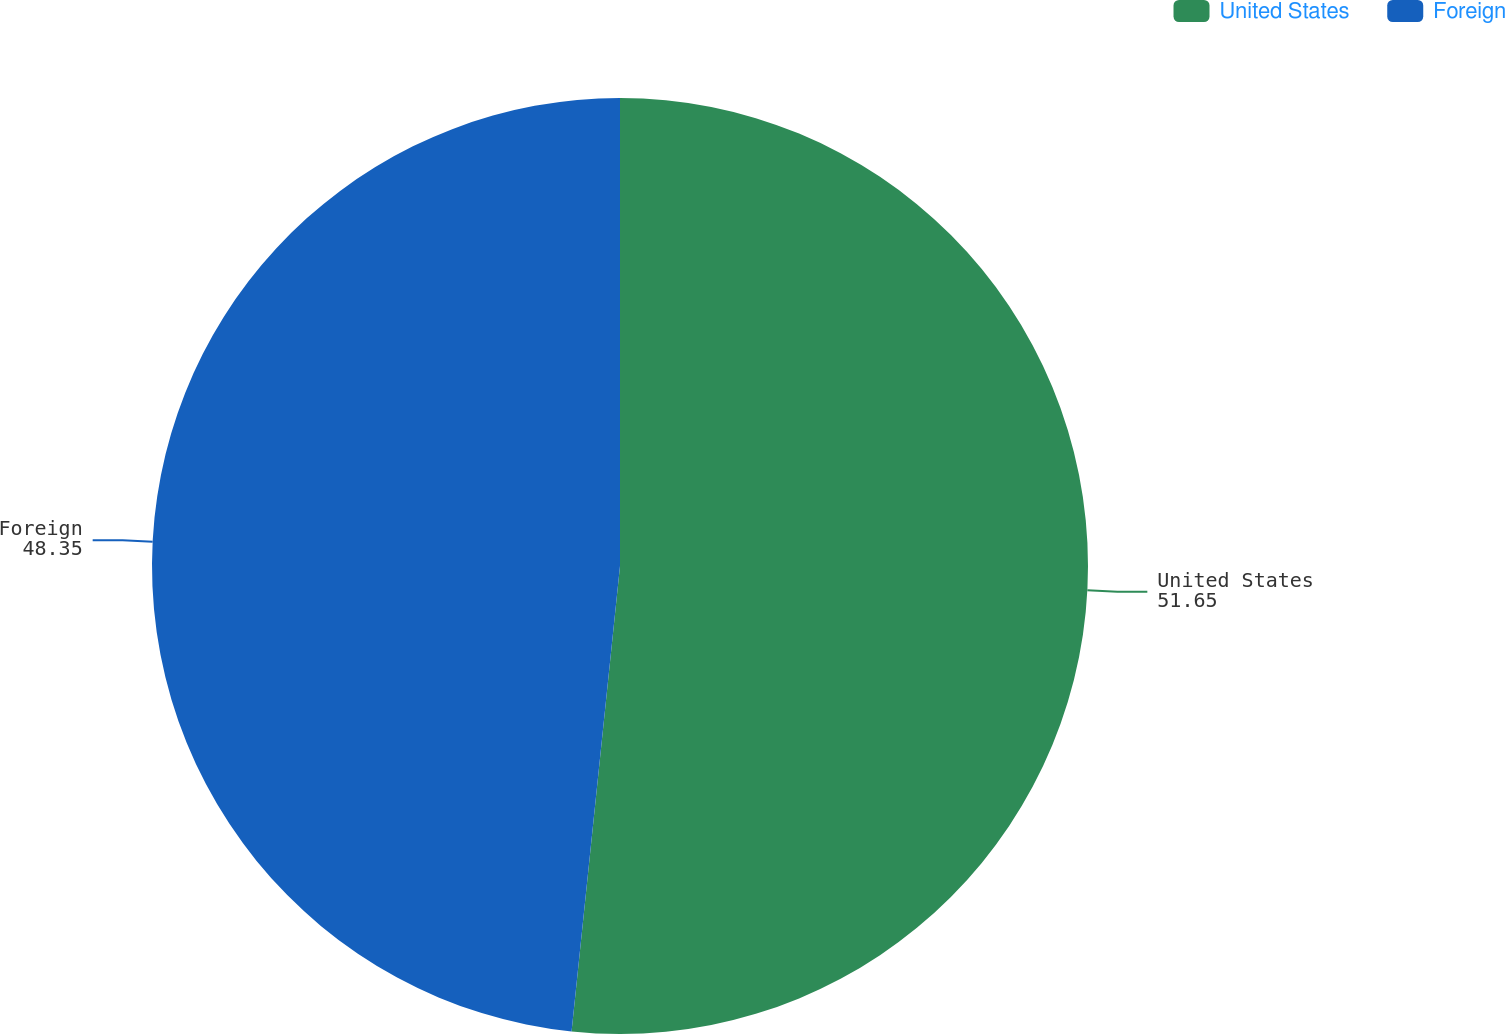Convert chart. <chart><loc_0><loc_0><loc_500><loc_500><pie_chart><fcel>United States<fcel>Foreign<nl><fcel>51.65%<fcel>48.35%<nl></chart> 